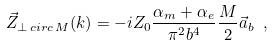<formula> <loc_0><loc_0><loc_500><loc_500>\vec { Z } _ { \bot \, c i r c \, M } ( k ) = - i Z _ { 0 } \frac { \alpha _ { m } + \alpha _ { e } } { \pi ^ { 2 } b ^ { 4 } } \frac { M } { 2 } \vec { a } _ { b } \ ,</formula> 